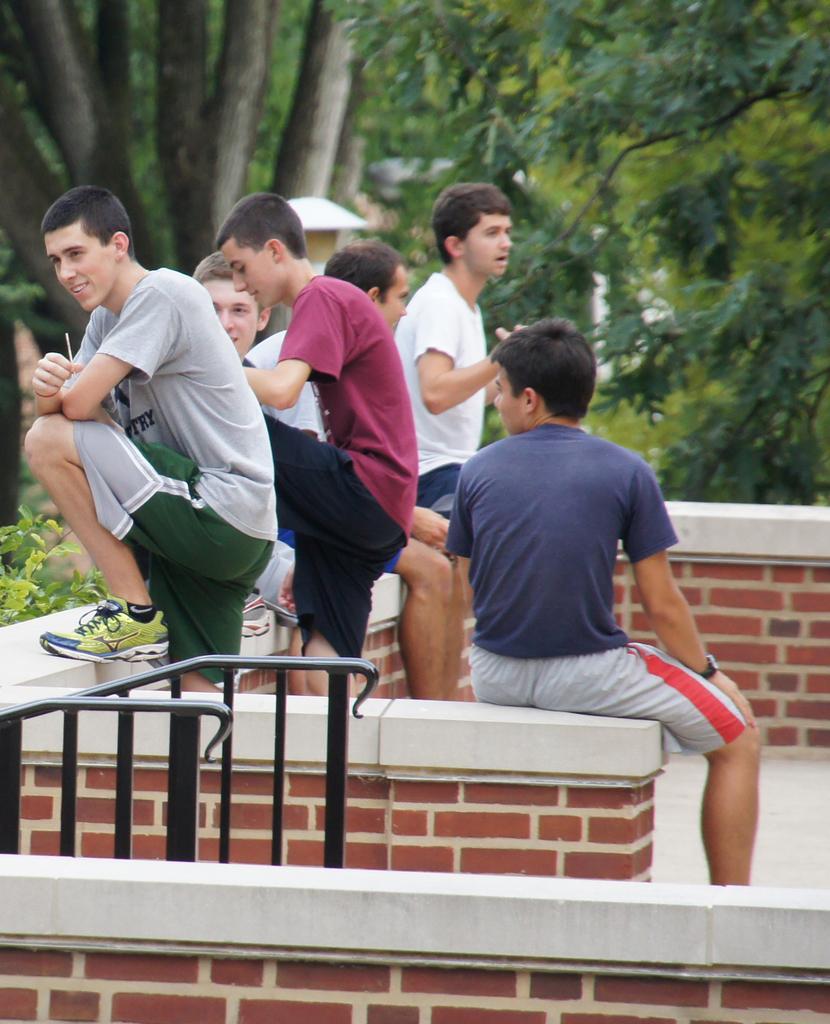Can you describe this image briefly? This picture shows few men, Couple of them are standing and few are seated and we see trees. 